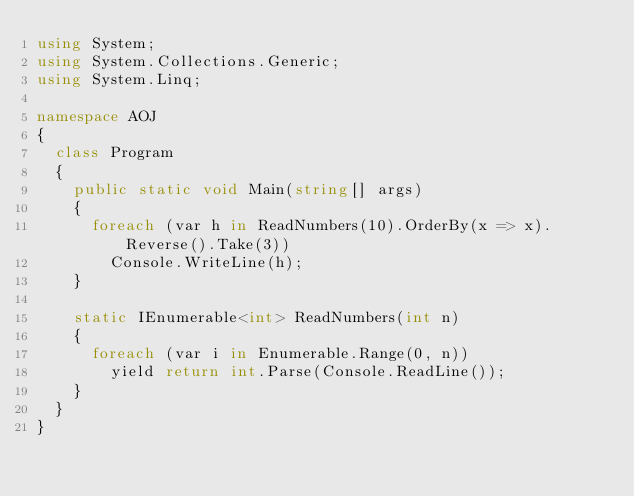<code> <loc_0><loc_0><loc_500><loc_500><_C#_>using System;
using System.Collections.Generic;
using System.Linq;

namespace AOJ
{
  class Program
  {
    public static void Main(string[] args)
    {
      foreach (var h in ReadNumbers(10).OrderBy(x => x).Reverse().Take(3))
        Console.WriteLine(h);
    }

    static IEnumerable<int> ReadNumbers(int n)
    {
      foreach (var i in Enumerable.Range(0, n))
        yield return int.Parse(Console.ReadLine());
    }
  }
}</code> 